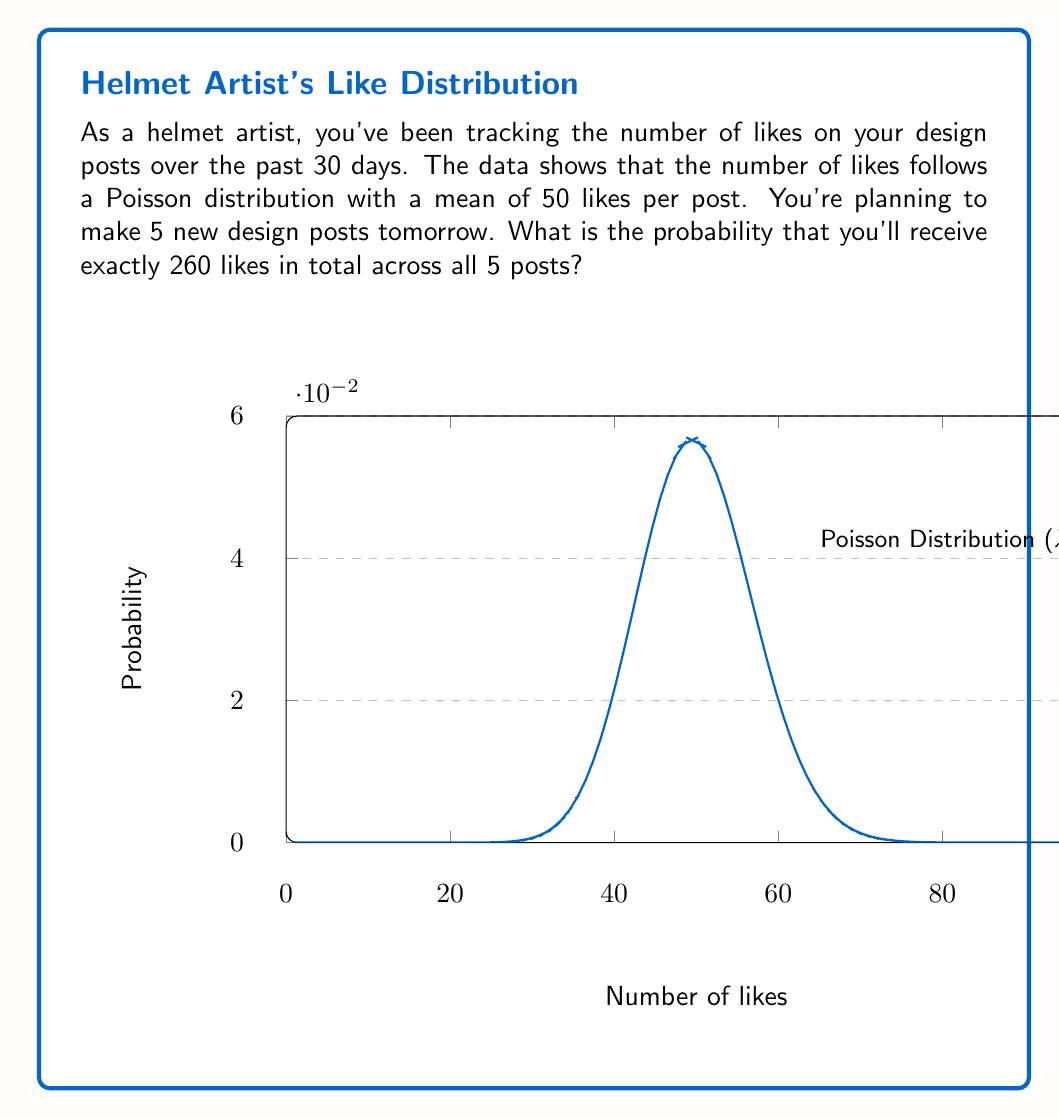Provide a solution to this math problem. Let's approach this step-by-step:

1) First, we need to understand what we're dealing with:
   - Each post follows a Poisson distribution with mean $\lambda = 50$
   - We're making 5 posts
   - We want the probability of getting 260 likes in total

2) The sum of independent Poisson distributions is also a Poisson distribution. The mean of this new distribution is the sum of the means of the individual distributions.

3) So, for 5 posts, our new Poisson distribution has a mean of:
   $\lambda_{total} = 5 \times 50 = 250$

4) Now, we're looking for the probability of getting exactly 260 likes with this new distribution.

5) The probability mass function for a Poisson distribution is:

   $P(X = k) = \frac{e^{-\lambda}\lambda^k}{k!}$

   Where $\lambda$ is the mean and $k$ is the number of occurrences.

6) Plugging in our values:
   $P(X = 260) = \frac{e^{-250}250^{260}}{260!}$

7) This can be calculated using a calculator or computer program:

   $P(X = 260) \approx 0.02508$

8) Convert to percentage: $0.02508 \times 100 \approx 2.508\%$
Answer: $2.508\%$ 